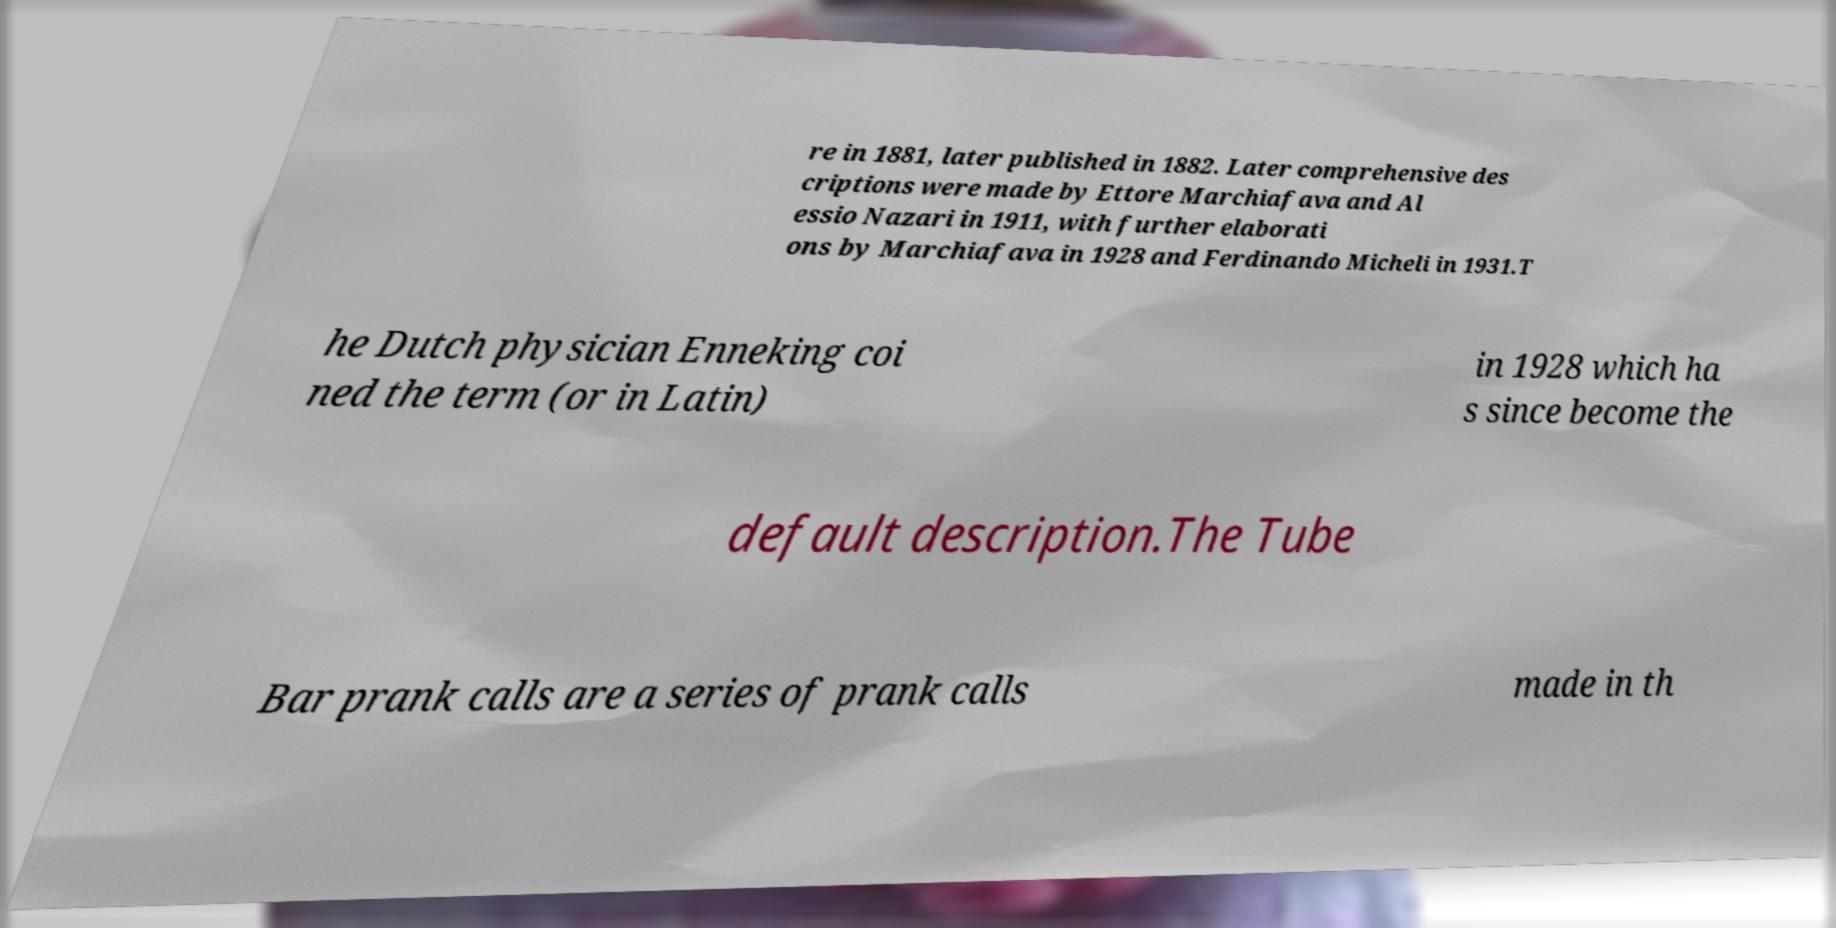Could you extract and type out the text from this image? re in 1881, later published in 1882. Later comprehensive des criptions were made by Ettore Marchiafava and Al essio Nazari in 1911, with further elaborati ons by Marchiafava in 1928 and Ferdinando Micheli in 1931.T he Dutch physician Enneking coi ned the term (or in Latin) in 1928 which ha s since become the default description.The Tube Bar prank calls are a series of prank calls made in th 